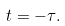<formula> <loc_0><loc_0><loc_500><loc_500>t = - \tau .</formula> 